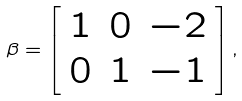<formula> <loc_0><loc_0><loc_500><loc_500>\beta = \left [ \begin{array} { c c c } 1 & 0 & - 2 \\ 0 & 1 & - 1 \end{array} \right ] ,</formula> 